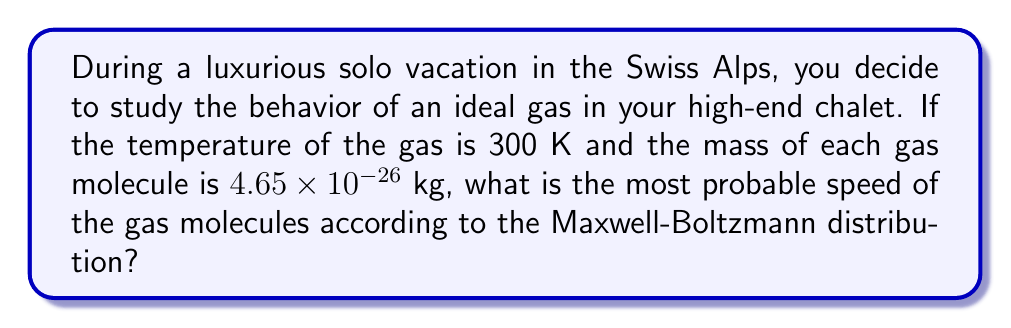Could you help me with this problem? Let's approach this step-by-step:

1) The Maxwell-Boltzmann distribution gives the probability density function for molecular speeds in an ideal gas. The most probable speed, $v_p$, is given by:

   $$v_p = \sqrt{\frac{2k_BT}{m}}$$

   Where:
   $k_B$ is the Boltzmann constant
   $T$ is the temperature in Kelvin
   $m$ is the mass of a single gas molecule

2) We're given:
   $T = 300$ K
   $m = 4.65 \times 10^{-26}$ kg

3) We need to know the Boltzmann constant:
   $k_B = 1.380649 \times 10^{-23}$ J/K

4) Now, let's substitute these values into our equation:

   $$v_p = \sqrt{\frac{2(1.380649 \times 10^{-23} \text{ J/K})(300 \text{ K})}{4.65 \times 10^{-26} \text{ kg}}}$$

5) Simplify inside the square root:

   $$v_p = \sqrt{\frac{8.28389 \times 10^{-21}}{4.65 \times 10^{-26}}}$$

6) Divide inside the square root:

   $$v_p = \sqrt{1.78147 \times 10^5}$$

7) Take the square root:

   $$v_p = 421.93 \text{ m/s}$$

8) Rounding to three significant figures:

   $$v_p = 422 \text{ m/s}$$
Answer: 422 m/s 